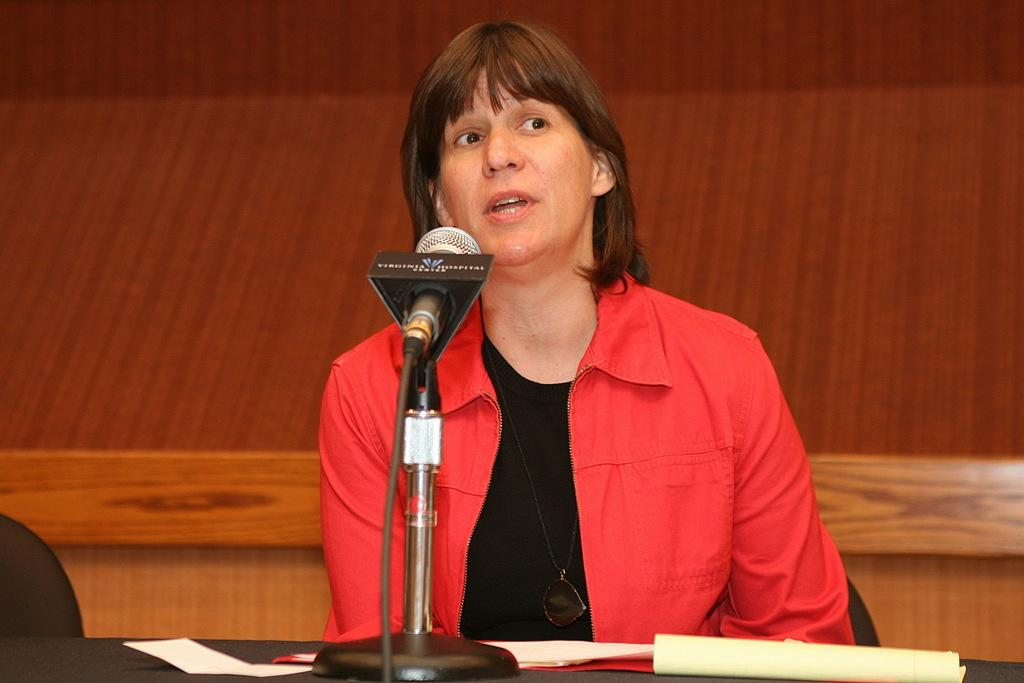What is the woman in the image doing? The woman is talking on a microphone. What is the woman wearing in the image? The woman is wearing a red jacket. What objects can be seen on the table in the image? There are papers on the table. What type of furniture is present in the image? There is a chair in the image. What can be seen in the background of the image? There is a wall in the background of the image. Can you tell me how many cows are grazing at the seashore in the image? There is no seashore or cows present in the image. 